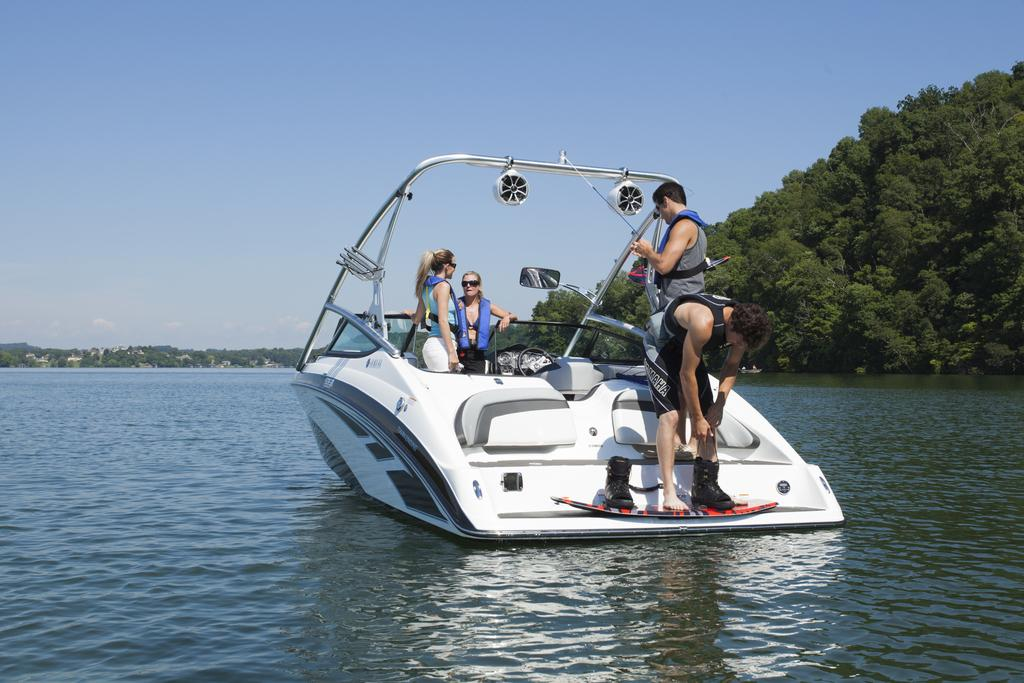What is the main subject of the image? The main subject of the image is a boat. Where is the boat located? The boat is on the water. Are there any people on the boat? Yes, there are people standing on the boat. What else can be seen in the image besides the boat and people? Trees and the sky are visible in the image. How many dogs are playing with a doll on the boat in the image? There are no dogs or dolls present in the image; it features a boat with people on it. 